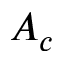Convert formula to latex. <formula><loc_0><loc_0><loc_500><loc_500>A _ { c }</formula> 